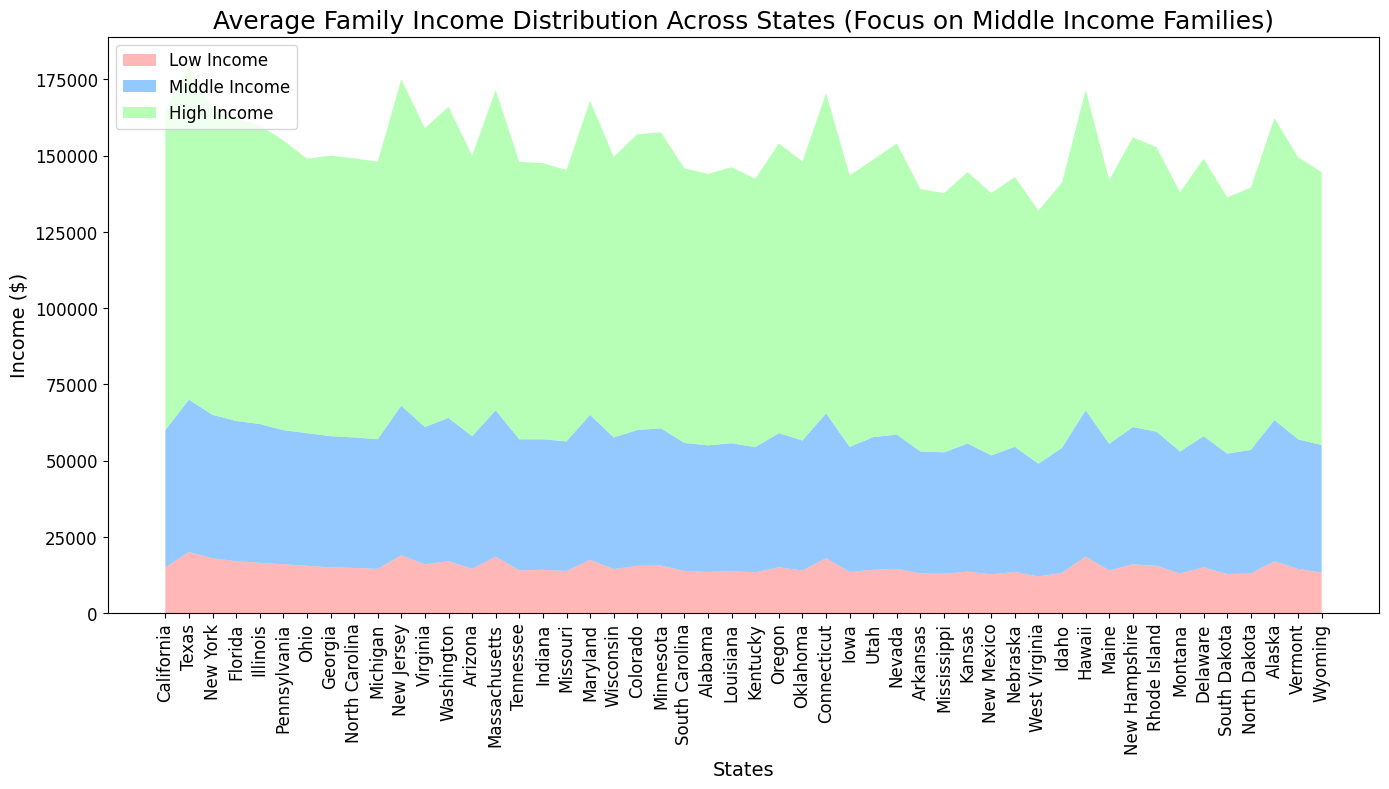What's the highest middle income among the states? Look for the tallest segment in the middle income part of the stacked area chart.
Answer: 50000 Which state has the lowest high income? Identify the shortest segment in the high income part of the stacked area chart.
Answer: West Virginia Among Florida, Texas, and New York, which state has the highest low income? Compare the heights of the Florida, Texas, and New York segments in the low income part of the chart.
Answer: Texas What is the combined average high income for California and Texas? Combine high incomes for California and Texas, then find the average: (105000 + 110000) / 2.
Answer: 107500 Which state has a higher middle income, Virginia or Florida? Compare the height of Virginia’s middle income segment with Florida’s middle income segment.
Answer: Virginia Considering middle income families, how many states have a middle income above 45000? Count the number of states with middle income segments taller than the 45000 mark.
Answer: 9 What is the sum of low and middle incomes for Michigan? Add the values for low and middle incomes: 14500 + 42500.
Answer: 57000 Is there a significant difference in high income between New Jersey and New York? Compare the heights of the high income segments for New Jersey and New York. New Jersey’s high income is 107000, and New York’s is 100000.
Answer: Yes Which state has the closest middle income to the average middle income of all states? Calculate the average middle income for all states and compare each state’s middle income to this average to find the closest match. First, total of middle incomes (add all middle incomes), then divide by the number of states (51).
Answer: Texas (avg is ~44500) Considering the visual attributes, why might middle income be the focus of this chart? The middle income segment is visually more prominent and often sits centrally in the chart, making it more noticeable and easy to compare across states.
Answer: More prominent visual focus 